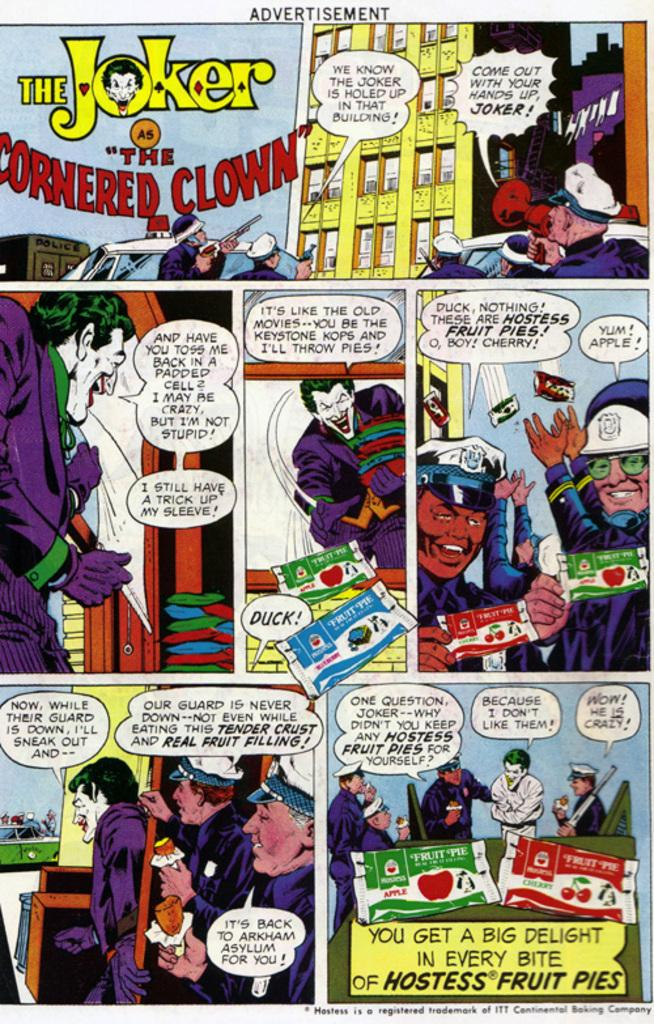Provide a one-sentence caption for the provided image. a comic that is for the Batmal villain called The Joker. 